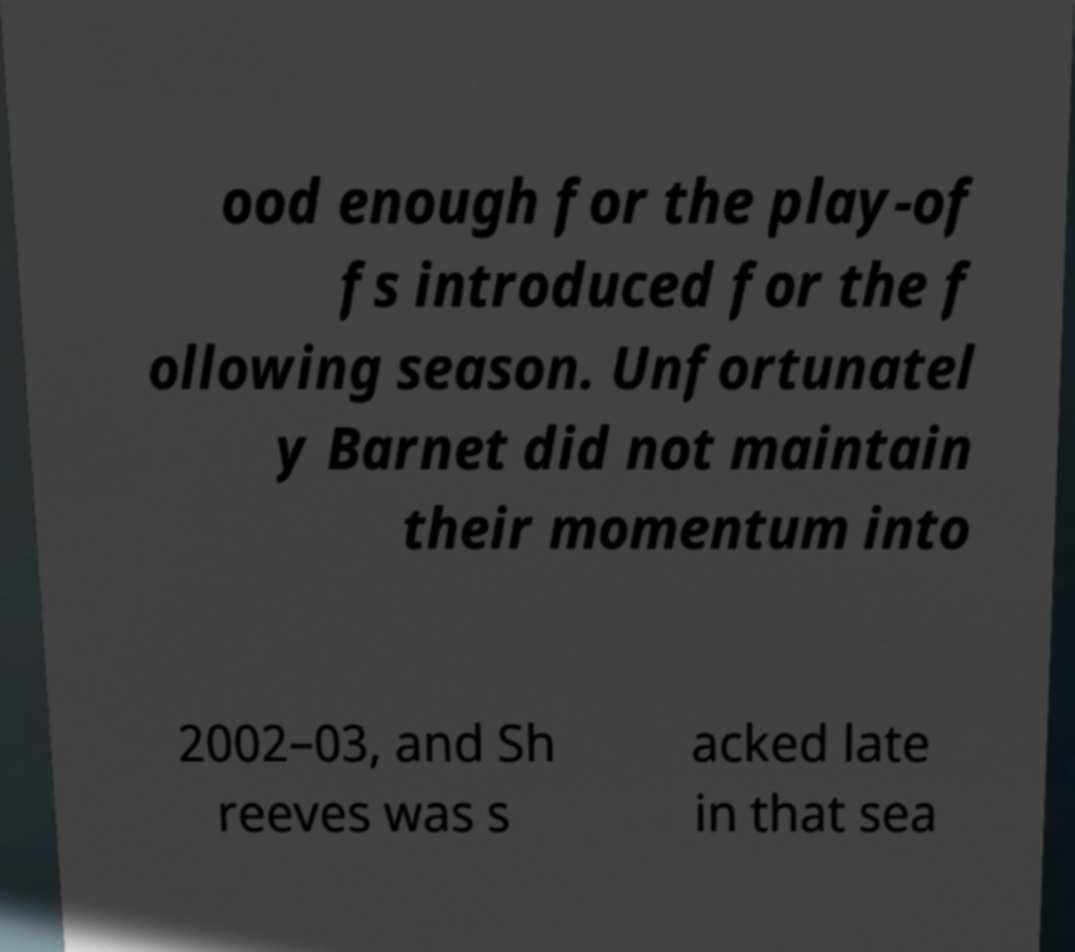Please identify and transcribe the text found in this image. ood enough for the play-of fs introduced for the f ollowing season. Unfortunatel y Barnet did not maintain their momentum into 2002–03, and Sh reeves was s acked late in that sea 